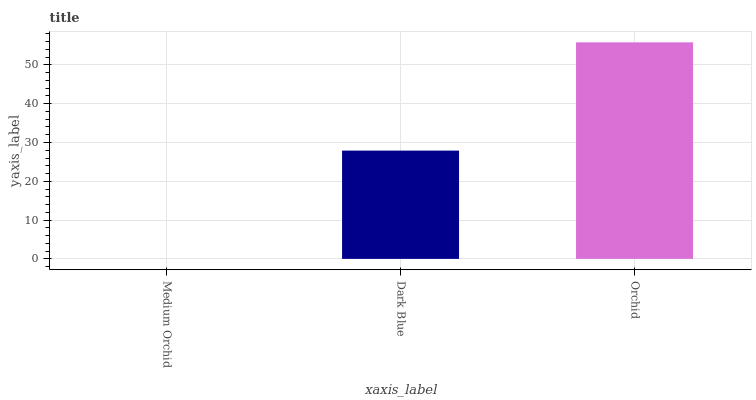Is Dark Blue the minimum?
Answer yes or no. No. Is Dark Blue the maximum?
Answer yes or no. No. Is Dark Blue greater than Medium Orchid?
Answer yes or no. Yes. Is Medium Orchid less than Dark Blue?
Answer yes or no. Yes. Is Medium Orchid greater than Dark Blue?
Answer yes or no. No. Is Dark Blue less than Medium Orchid?
Answer yes or no. No. Is Dark Blue the high median?
Answer yes or no. Yes. Is Dark Blue the low median?
Answer yes or no. Yes. Is Medium Orchid the high median?
Answer yes or no. No. Is Medium Orchid the low median?
Answer yes or no. No. 